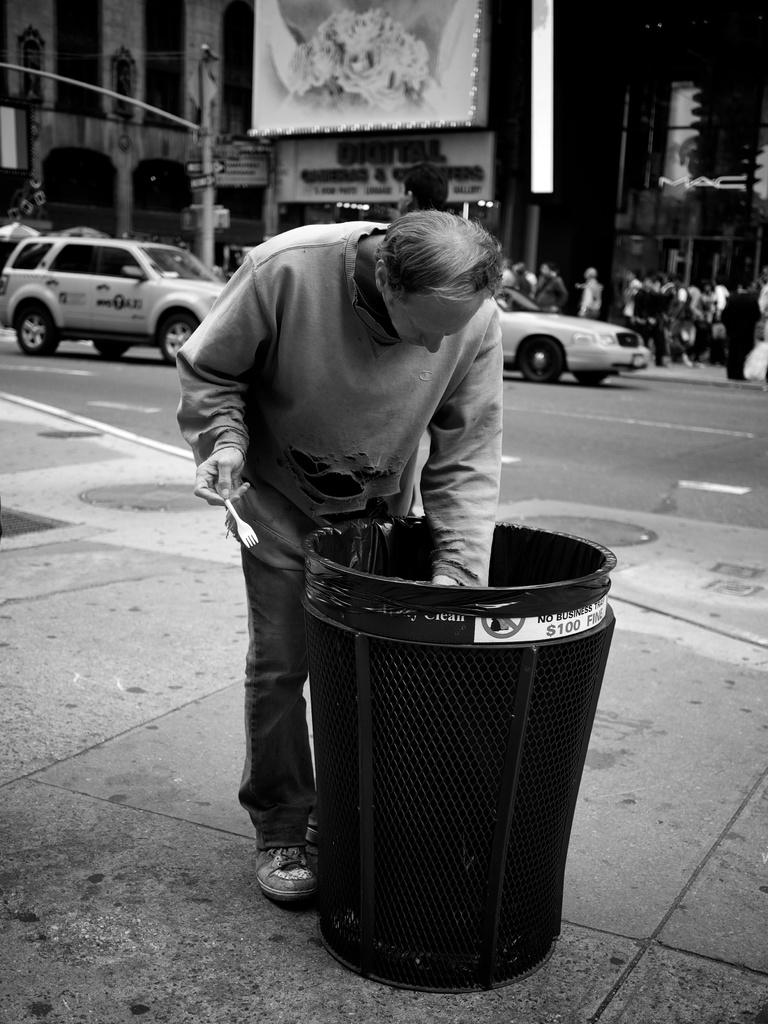<image>
Write a terse but informative summary of the picture. A man digging in a trash can with a sticker on it saying no business trash or $100 fine. 